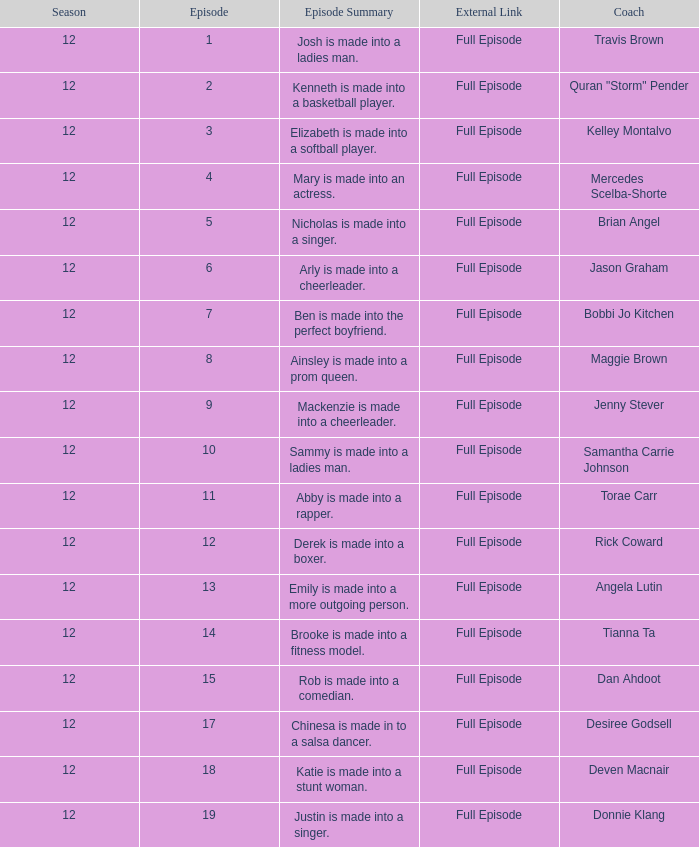Name the episode for travis brown 1.0. 